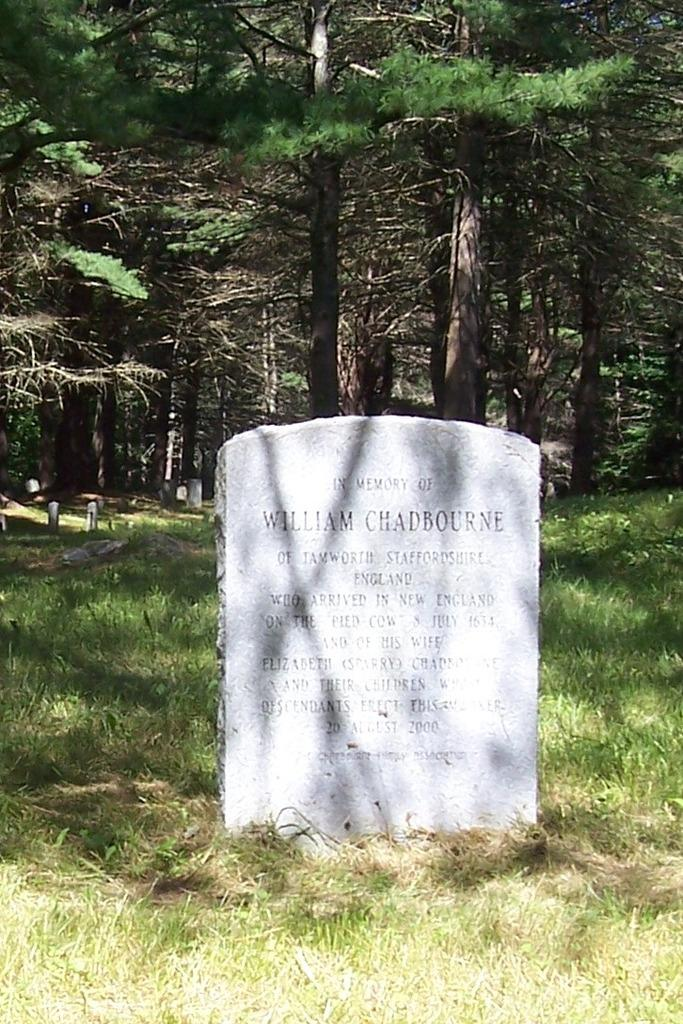What type of surface is visible in the image? There is a grass surface in the image. What can be found on the grass surface? There is a gravestone with information in the image. What can be seen in the distance in the image? There are trees visible in the background of the image. What type of carriage is parked next to the gravestone in the image? There is no carriage present in the image; it only features a grass surface, a gravestone, and trees in the background. 